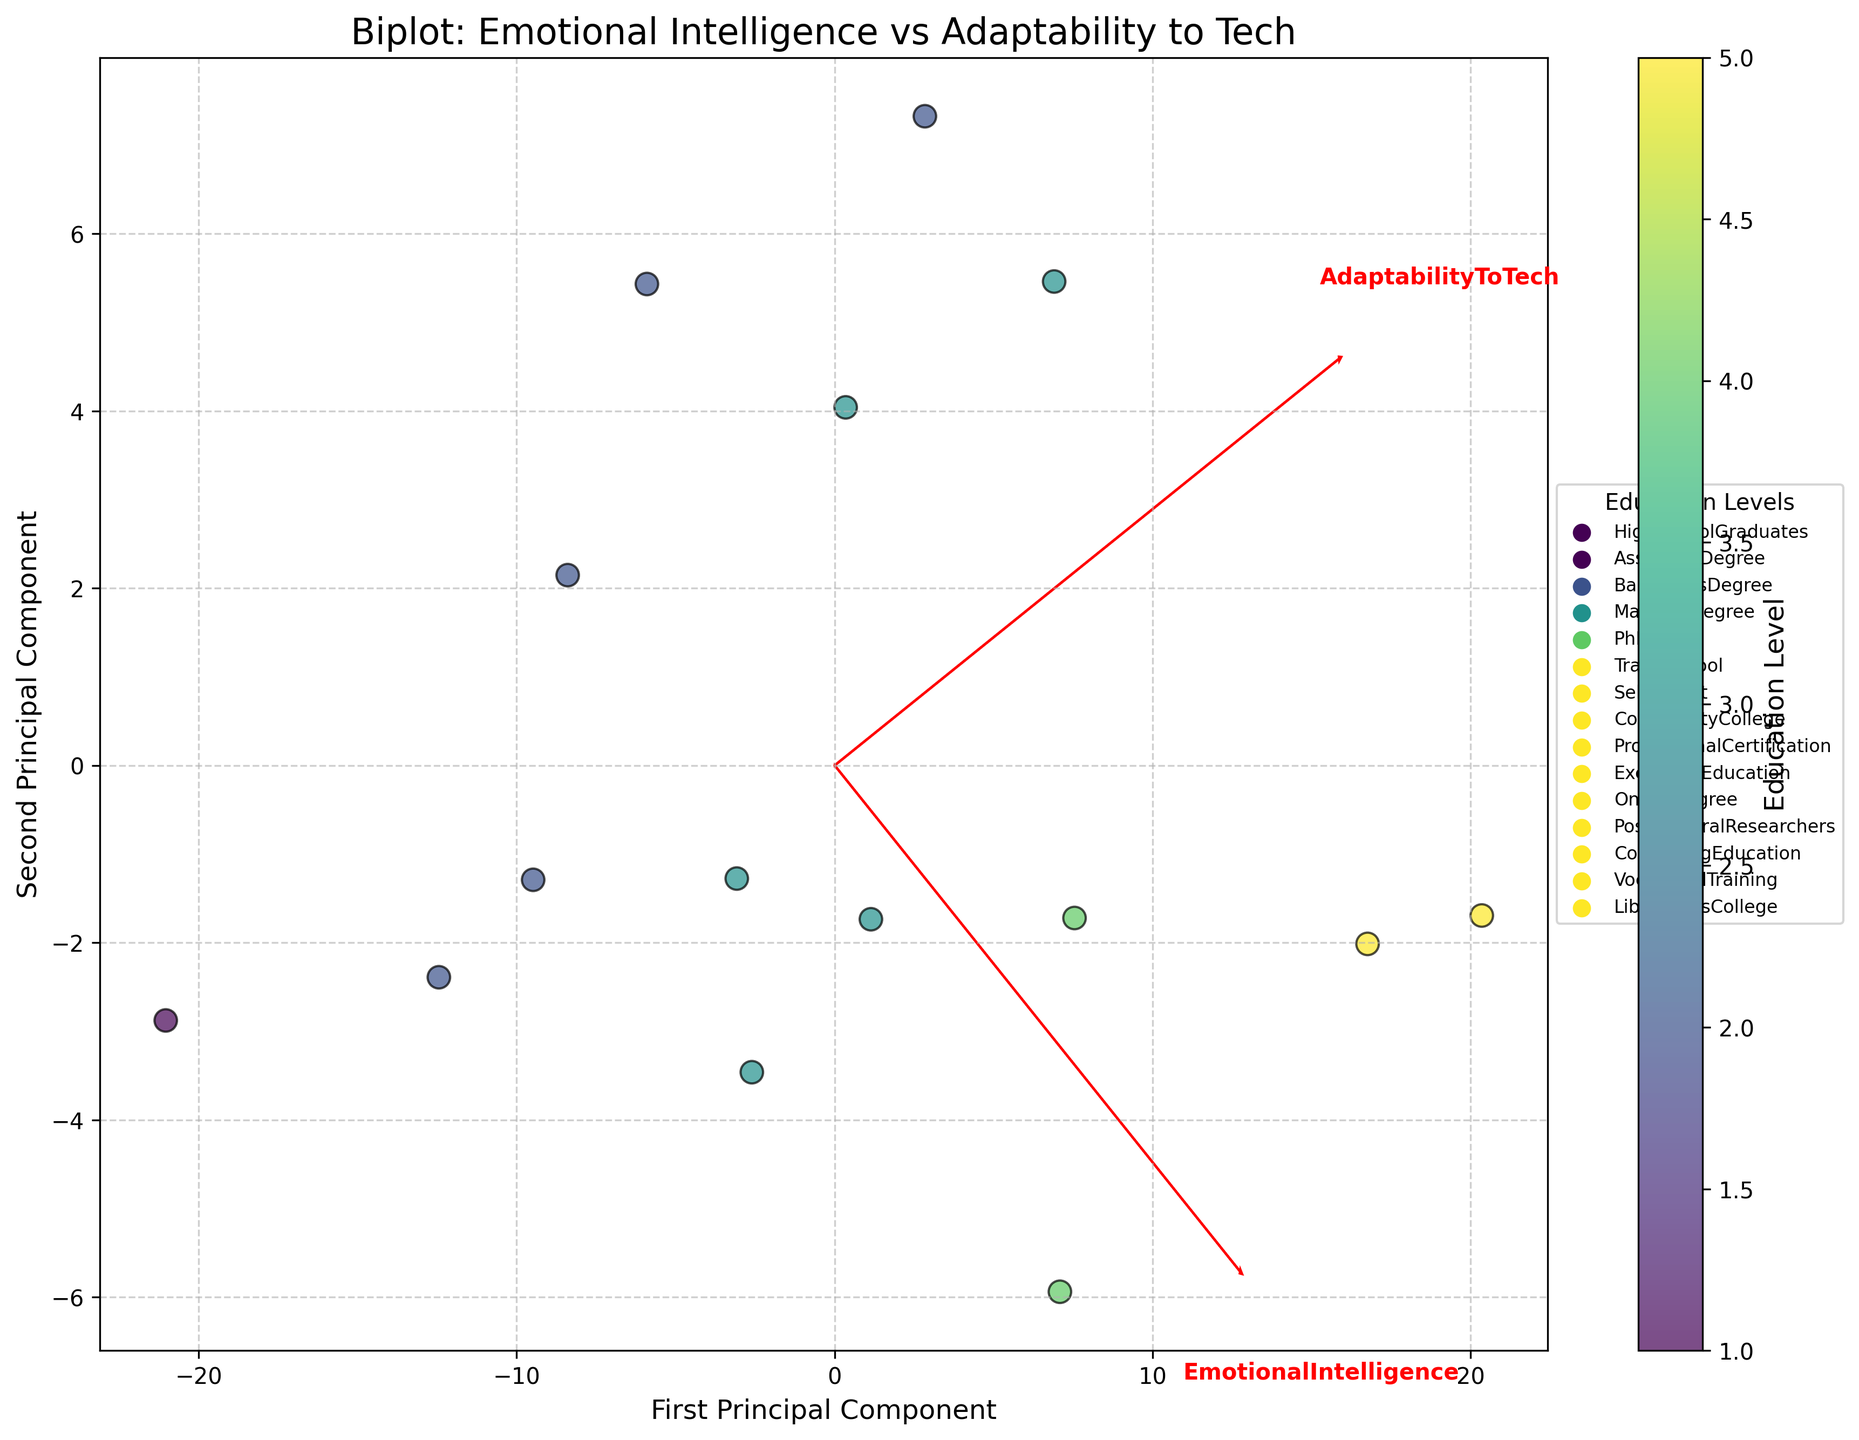What is the title of the plot? The title is displayed at the top of the plot and reads "Biplot: Emotional Intelligence vs Adaptability to Tech."
Answer: Biplot: Emotional Intelligence vs Adaptability to Tech How many data points are shown in the plot? The scatter plot has 15 data points, each representing a different education level. The legend and scatter points together provide this visual information.
Answer: 15 Which education level shows the highest values for both Emotional Intelligence and Adaptability to Tech? The data point labeled "Postdoctoral Researchers" has the highest values on both axes. This can be seen on the upper right corner of the plot.
Answer: Postdoctoral Researchers What does the color scheme represent in the plot? The color gradient represents different education levels, with the color bar on the right side of the plot indicating the mapping.
Answer: Education Level Do variables Emotional Intelligence and Adaptability to Tech appear positively correlated? Both variable vectors point in similar directions, suggesting a positive correlation. The data points distribution also supports this observation.
Answer: Yes Which education level has the lowest Emotional Intelligence value, and what is that value approximately? The data point for "HighSchoolGraduates" is the farthest left along the Emotional Intelligence axis, indicating the lowest value. The scatter point aligns around 65 on the Emotional Intelligence axis.
Answer: HighSchoolGraduates, 65 What's the average Adaptability to Tech value for the top three education levels based on Emotional Intelligence? The top three education levels are "Postdoctoral Researchers," "PhD," and "Master's Degree." Their Adaptability to Tech values are 88, 85, and 78 respectively. (88 + 85 + 78) / 3 = 83.67.
Answer: 83.67 How does the variable "Adaptability to Tech" vector compare to "Emotional Intelligence" vector in direction? The "Adaptability to Tech" vector is slightly diverged but generally in the same direction as the "Emotional Intelligence" vector, indicating a positive relation with minor differences.
Answer: Similar but diverged Between "TradeSchool" and "CommunityCollege," which has greater adaptability to technological changes? "TradeSchool" is positioned higher on the Adaptability to Tech axis than "CommunityCollege."
Answer: TradeSchool Is "Professional Certification" more aligned with Emotional Intelligence or Adaptability to Tech? The data point for "Professional Certification" is farther along the Adaptability to Tech axis and slightly behind on the Emotional Intelligence axis compared to other points nearby, indicating it is more aligned with Adaptability to Tech.
Answer: Adaptability to Tech 